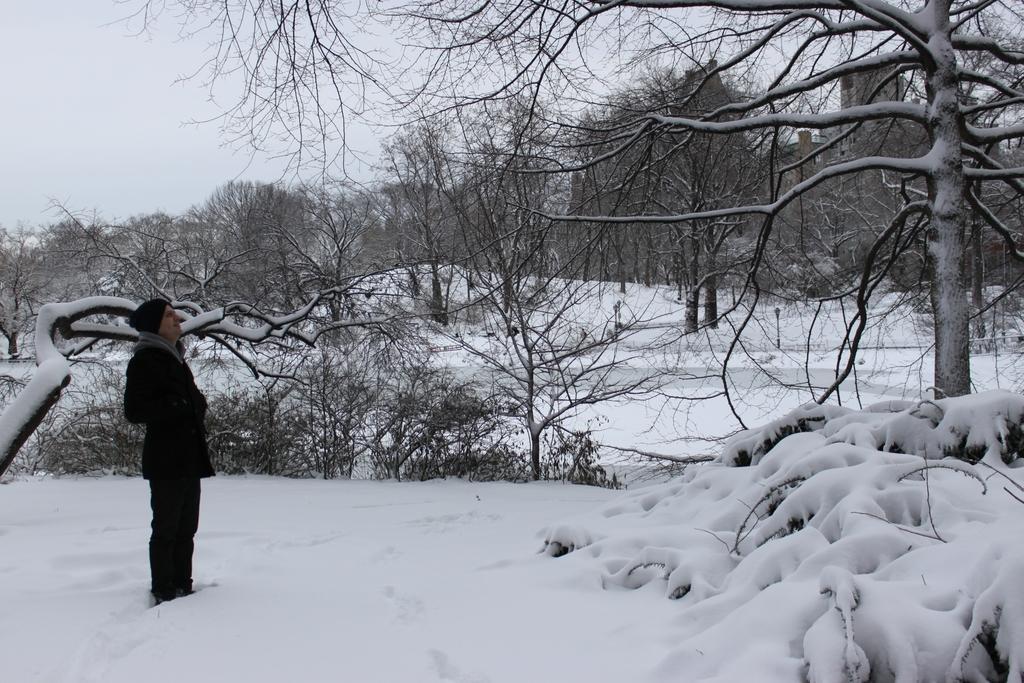Please provide a concise description of this image. In this image a person wearing a cap is standing on the land which is covered with the sow. Background there are plants and trees. Top of the image there is sky. 